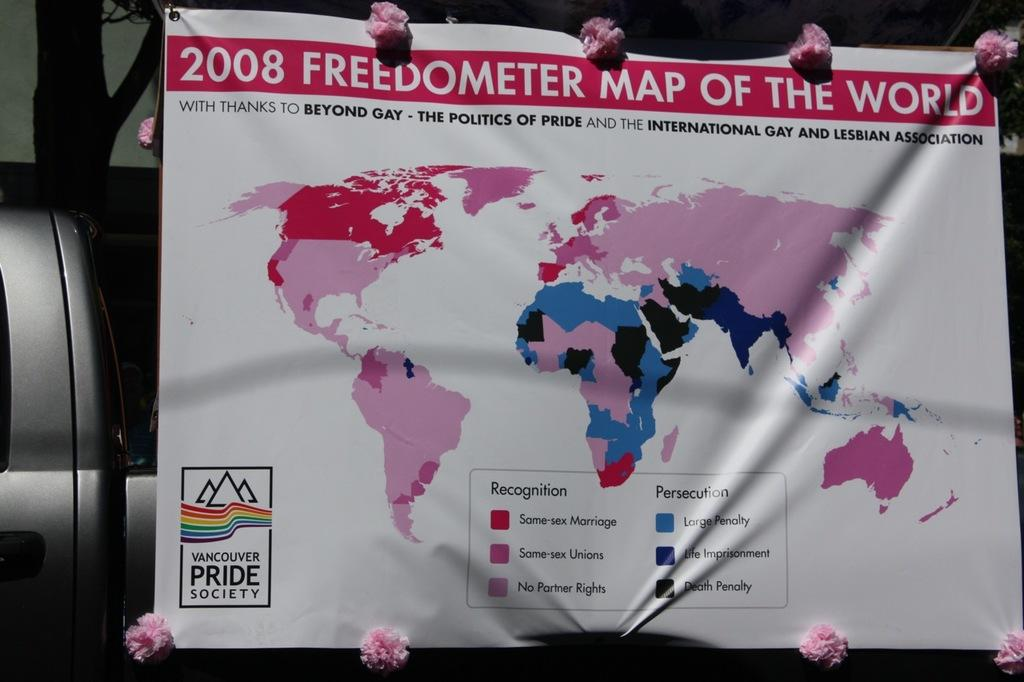Provide a one-sentence caption for the provided image. A map of the world with the words freedometer map of the world on the top. 